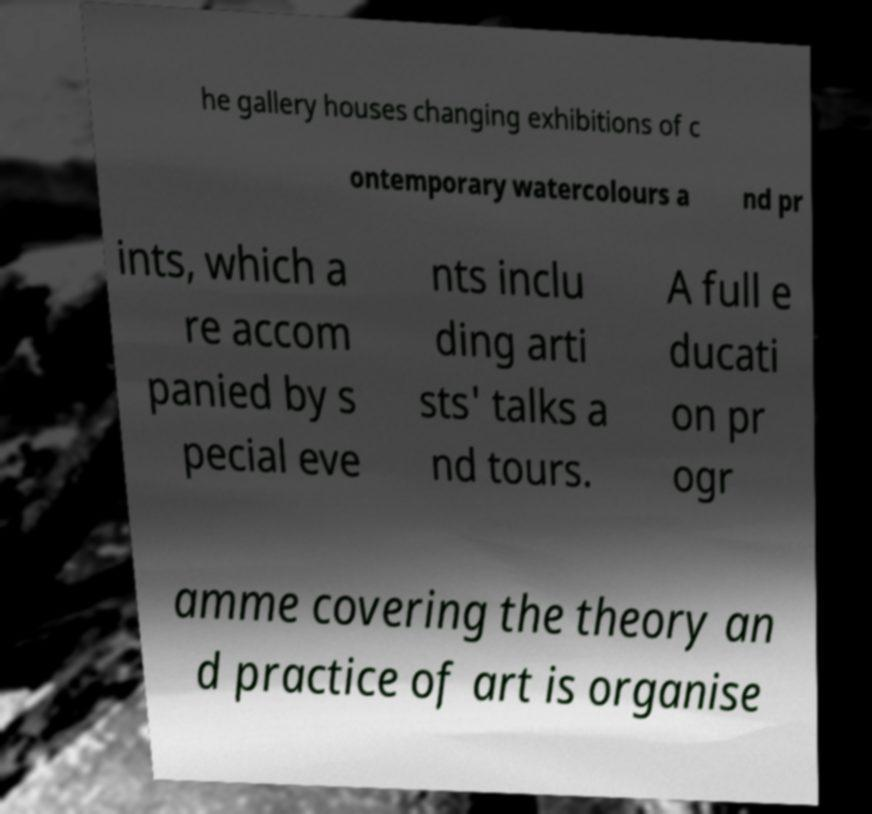Could you extract and type out the text from this image? he gallery houses changing exhibitions of c ontemporary watercolours a nd pr ints, which a re accom panied by s pecial eve nts inclu ding arti sts' talks a nd tours. A full e ducati on pr ogr amme covering the theory an d practice of art is organise 